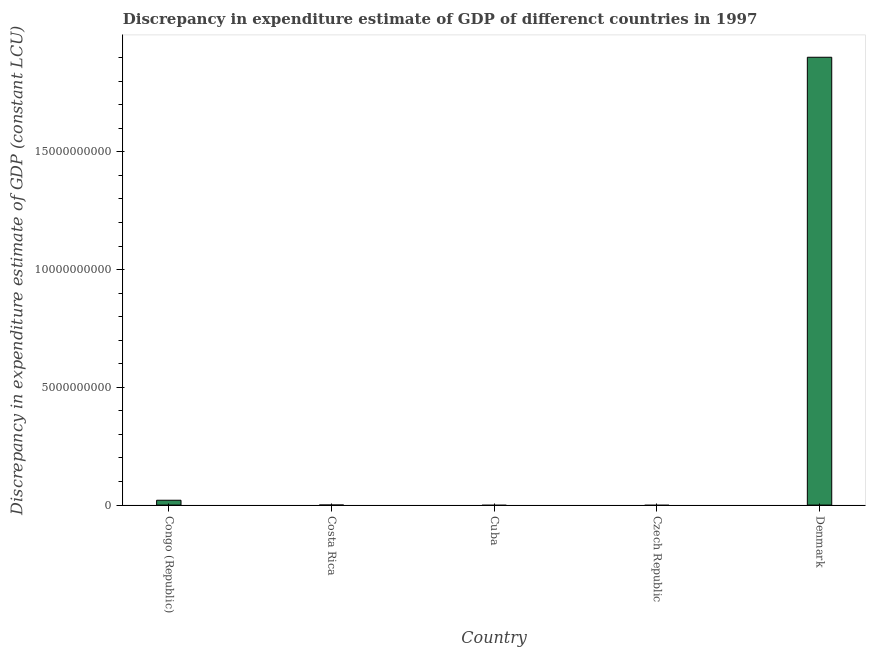Does the graph contain grids?
Provide a short and direct response. No. What is the title of the graph?
Keep it short and to the point. Discrepancy in expenditure estimate of GDP of differenct countries in 1997. What is the label or title of the Y-axis?
Ensure brevity in your answer.  Discrepancy in expenditure estimate of GDP (constant LCU). Across all countries, what is the maximum discrepancy in expenditure estimate of gdp?
Make the answer very short. 1.90e+1. What is the sum of the discrepancy in expenditure estimate of gdp?
Provide a succinct answer. 1.92e+1. What is the average discrepancy in expenditure estimate of gdp per country?
Provide a short and direct response. 3.84e+09. What is the median discrepancy in expenditure estimate of gdp?
Offer a terse response. 0. In how many countries, is the discrepancy in expenditure estimate of gdp greater than 2000000000 LCU?
Make the answer very short. 1. What is the ratio of the discrepancy in expenditure estimate of gdp in Congo (Republic) to that in Denmark?
Your answer should be compact. 0.01. What is the difference between the highest and the lowest discrepancy in expenditure estimate of gdp?
Your answer should be compact. 1.90e+1. How many bars are there?
Make the answer very short. 2. Are all the bars in the graph horizontal?
Provide a short and direct response. No. What is the difference between two consecutive major ticks on the Y-axis?
Give a very brief answer. 5.00e+09. Are the values on the major ticks of Y-axis written in scientific E-notation?
Your answer should be compact. No. What is the Discrepancy in expenditure estimate of GDP (constant LCU) in Congo (Republic)?
Make the answer very short. 2.05e+08. What is the Discrepancy in expenditure estimate of GDP (constant LCU) in Czech Republic?
Keep it short and to the point. 0. What is the Discrepancy in expenditure estimate of GDP (constant LCU) of Denmark?
Give a very brief answer. 1.90e+1. What is the difference between the Discrepancy in expenditure estimate of GDP (constant LCU) in Congo (Republic) and Denmark?
Your answer should be compact. -1.88e+1. What is the ratio of the Discrepancy in expenditure estimate of GDP (constant LCU) in Congo (Republic) to that in Denmark?
Provide a succinct answer. 0.01. 